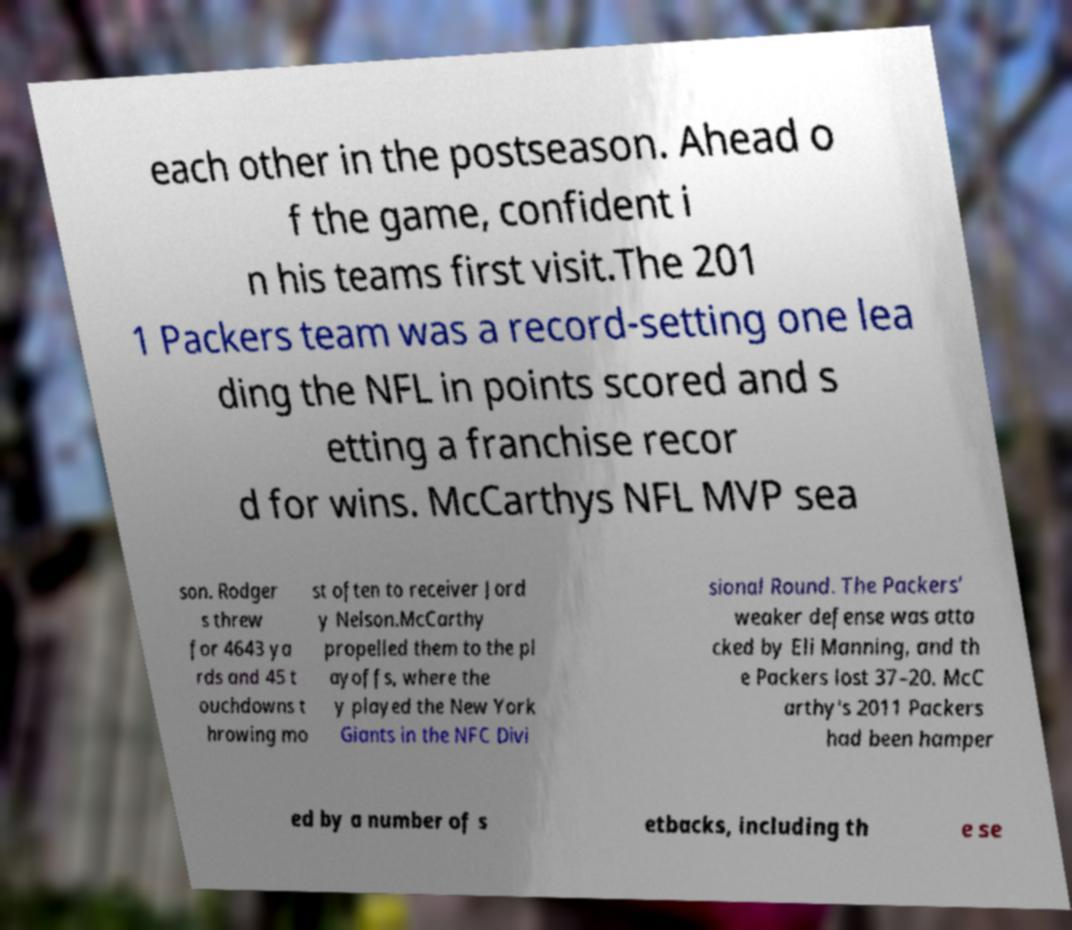There's text embedded in this image that I need extracted. Can you transcribe it verbatim? each other in the postseason. Ahead o f the game, confident i n his teams first visit.The 201 1 Packers team was a record-setting one lea ding the NFL in points scored and s etting a franchise recor d for wins. McCarthys NFL MVP sea son. Rodger s threw for 4643 ya rds and 45 t ouchdowns t hrowing mo st often to receiver Jord y Nelson.McCarthy propelled them to the pl ayoffs, where the y played the New York Giants in the NFC Divi sional Round. The Packers’ weaker defense was atta cked by Eli Manning, and th e Packers lost 37–20. McC arthy's 2011 Packers had been hamper ed by a number of s etbacks, including th e se 